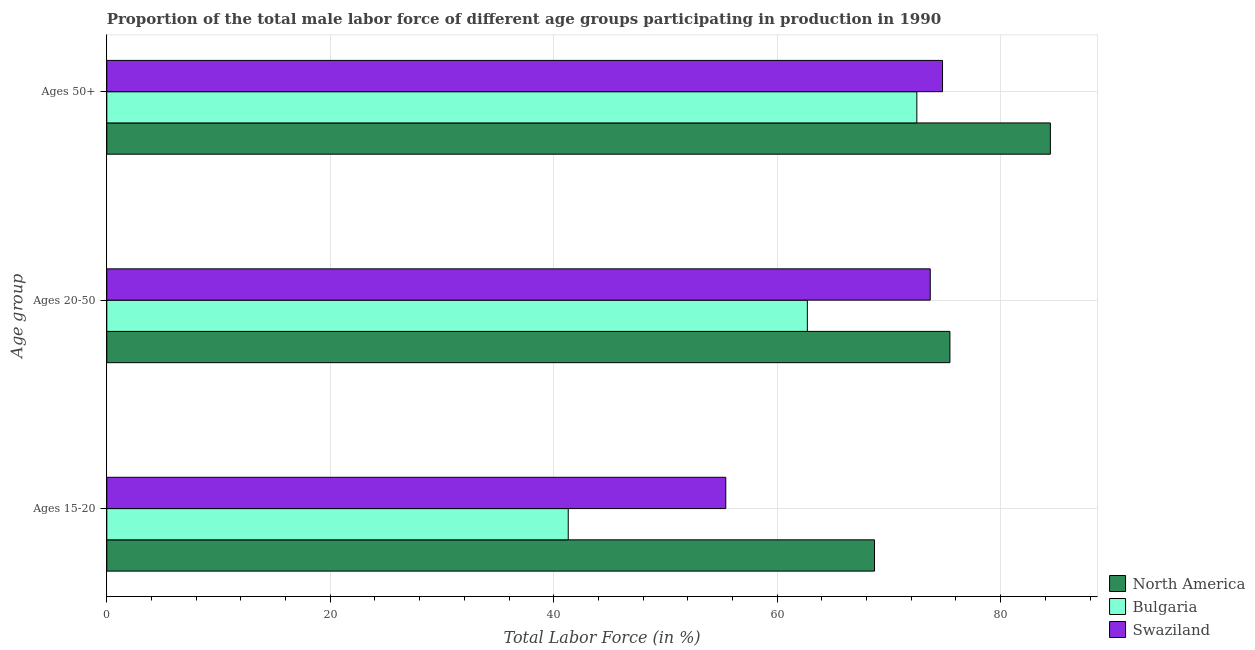Are the number of bars on each tick of the Y-axis equal?
Provide a short and direct response. Yes. What is the label of the 1st group of bars from the top?
Offer a terse response. Ages 50+. What is the percentage of male labor force within the age group 15-20 in Swaziland?
Your answer should be very brief. 55.4. Across all countries, what is the maximum percentage of male labor force within the age group 20-50?
Your answer should be very brief. 75.46. Across all countries, what is the minimum percentage of male labor force within the age group 20-50?
Provide a succinct answer. 62.7. In which country was the percentage of male labor force above age 50 maximum?
Your response must be concise. North America. What is the total percentage of male labor force above age 50 in the graph?
Provide a short and direct response. 231.75. What is the difference between the percentage of male labor force above age 50 in Swaziland and that in Bulgaria?
Provide a succinct answer. 2.3. What is the difference between the percentage of male labor force within the age group 20-50 in North America and the percentage of male labor force above age 50 in Bulgaria?
Give a very brief answer. 2.96. What is the average percentage of male labor force within the age group 20-50 per country?
Ensure brevity in your answer.  70.62. What is the difference between the percentage of male labor force within the age group 15-20 and percentage of male labor force above age 50 in North America?
Keep it short and to the point. -15.74. What is the ratio of the percentage of male labor force above age 50 in North America to that in Bulgaria?
Make the answer very short. 1.16. What is the difference between the highest and the second highest percentage of male labor force above age 50?
Make the answer very short. 9.65. What is the difference between the highest and the lowest percentage of male labor force within the age group 20-50?
Provide a short and direct response. 12.76. In how many countries, is the percentage of male labor force within the age group 15-20 greater than the average percentage of male labor force within the age group 15-20 taken over all countries?
Your answer should be very brief. 2. What does the 3rd bar from the bottom in Ages 50+ represents?
Provide a succinct answer. Swaziland. How many countries are there in the graph?
Keep it short and to the point. 3. Are the values on the major ticks of X-axis written in scientific E-notation?
Make the answer very short. No. Does the graph contain grids?
Ensure brevity in your answer.  Yes. Where does the legend appear in the graph?
Your response must be concise. Bottom right. How many legend labels are there?
Keep it short and to the point. 3. What is the title of the graph?
Your answer should be very brief. Proportion of the total male labor force of different age groups participating in production in 1990. What is the label or title of the X-axis?
Give a very brief answer. Total Labor Force (in %). What is the label or title of the Y-axis?
Keep it short and to the point. Age group. What is the Total Labor Force (in %) of North America in Ages 15-20?
Give a very brief answer. 68.71. What is the Total Labor Force (in %) of Bulgaria in Ages 15-20?
Provide a short and direct response. 41.3. What is the Total Labor Force (in %) of Swaziland in Ages 15-20?
Offer a very short reply. 55.4. What is the Total Labor Force (in %) of North America in Ages 20-50?
Provide a succinct answer. 75.46. What is the Total Labor Force (in %) of Bulgaria in Ages 20-50?
Offer a very short reply. 62.7. What is the Total Labor Force (in %) in Swaziland in Ages 20-50?
Your response must be concise. 73.7. What is the Total Labor Force (in %) in North America in Ages 50+?
Ensure brevity in your answer.  84.45. What is the Total Labor Force (in %) in Bulgaria in Ages 50+?
Your answer should be very brief. 72.5. What is the Total Labor Force (in %) of Swaziland in Ages 50+?
Keep it short and to the point. 74.8. Across all Age group, what is the maximum Total Labor Force (in %) of North America?
Your response must be concise. 84.45. Across all Age group, what is the maximum Total Labor Force (in %) in Bulgaria?
Your response must be concise. 72.5. Across all Age group, what is the maximum Total Labor Force (in %) of Swaziland?
Keep it short and to the point. 74.8. Across all Age group, what is the minimum Total Labor Force (in %) of North America?
Your response must be concise. 68.71. Across all Age group, what is the minimum Total Labor Force (in %) in Bulgaria?
Offer a terse response. 41.3. Across all Age group, what is the minimum Total Labor Force (in %) in Swaziland?
Your answer should be very brief. 55.4. What is the total Total Labor Force (in %) of North America in the graph?
Offer a very short reply. 228.63. What is the total Total Labor Force (in %) of Bulgaria in the graph?
Make the answer very short. 176.5. What is the total Total Labor Force (in %) in Swaziland in the graph?
Give a very brief answer. 203.9. What is the difference between the Total Labor Force (in %) in North America in Ages 15-20 and that in Ages 20-50?
Your response must be concise. -6.75. What is the difference between the Total Labor Force (in %) of Bulgaria in Ages 15-20 and that in Ages 20-50?
Your response must be concise. -21.4. What is the difference between the Total Labor Force (in %) in Swaziland in Ages 15-20 and that in Ages 20-50?
Make the answer very short. -18.3. What is the difference between the Total Labor Force (in %) in North America in Ages 15-20 and that in Ages 50+?
Give a very brief answer. -15.74. What is the difference between the Total Labor Force (in %) in Bulgaria in Ages 15-20 and that in Ages 50+?
Your answer should be compact. -31.2. What is the difference between the Total Labor Force (in %) in Swaziland in Ages 15-20 and that in Ages 50+?
Provide a succinct answer. -19.4. What is the difference between the Total Labor Force (in %) in North America in Ages 20-50 and that in Ages 50+?
Keep it short and to the point. -8.99. What is the difference between the Total Labor Force (in %) of Bulgaria in Ages 20-50 and that in Ages 50+?
Your answer should be compact. -9.8. What is the difference between the Total Labor Force (in %) in Swaziland in Ages 20-50 and that in Ages 50+?
Keep it short and to the point. -1.1. What is the difference between the Total Labor Force (in %) of North America in Ages 15-20 and the Total Labor Force (in %) of Bulgaria in Ages 20-50?
Keep it short and to the point. 6.01. What is the difference between the Total Labor Force (in %) in North America in Ages 15-20 and the Total Labor Force (in %) in Swaziland in Ages 20-50?
Ensure brevity in your answer.  -4.99. What is the difference between the Total Labor Force (in %) of Bulgaria in Ages 15-20 and the Total Labor Force (in %) of Swaziland in Ages 20-50?
Ensure brevity in your answer.  -32.4. What is the difference between the Total Labor Force (in %) of North America in Ages 15-20 and the Total Labor Force (in %) of Bulgaria in Ages 50+?
Give a very brief answer. -3.79. What is the difference between the Total Labor Force (in %) in North America in Ages 15-20 and the Total Labor Force (in %) in Swaziland in Ages 50+?
Keep it short and to the point. -6.09. What is the difference between the Total Labor Force (in %) in Bulgaria in Ages 15-20 and the Total Labor Force (in %) in Swaziland in Ages 50+?
Provide a short and direct response. -33.5. What is the difference between the Total Labor Force (in %) of North America in Ages 20-50 and the Total Labor Force (in %) of Bulgaria in Ages 50+?
Your response must be concise. 2.96. What is the difference between the Total Labor Force (in %) of North America in Ages 20-50 and the Total Labor Force (in %) of Swaziland in Ages 50+?
Offer a terse response. 0.66. What is the average Total Labor Force (in %) in North America per Age group?
Ensure brevity in your answer.  76.21. What is the average Total Labor Force (in %) in Bulgaria per Age group?
Provide a succinct answer. 58.83. What is the average Total Labor Force (in %) in Swaziland per Age group?
Offer a terse response. 67.97. What is the difference between the Total Labor Force (in %) in North America and Total Labor Force (in %) in Bulgaria in Ages 15-20?
Your answer should be compact. 27.41. What is the difference between the Total Labor Force (in %) of North America and Total Labor Force (in %) of Swaziland in Ages 15-20?
Offer a very short reply. 13.31. What is the difference between the Total Labor Force (in %) of Bulgaria and Total Labor Force (in %) of Swaziland in Ages 15-20?
Provide a succinct answer. -14.1. What is the difference between the Total Labor Force (in %) in North America and Total Labor Force (in %) in Bulgaria in Ages 20-50?
Your response must be concise. 12.76. What is the difference between the Total Labor Force (in %) of North America and Total Labor Force (in %) of Swaziland in Ages 20-50?
Your answer should be compact. 1.76. What is the difference between the Total Labor Force (in %) in Bulgaria and Total Labor Force (in %) in Swaziland in Ages 20-50?
Give a very brief answer. -11. What is the difference between the Total Labor Force (in %) in North America and Total Labor Force (in %) in Bulgaria in Ages 50+?
Offer a terse response. 11.95. What is the difference between the Total Labor Force (in %) of North America and Total Labor Force (in %) of Swaziland in Ages 50+?
Provide a succinct answer. 9.65. What is the difference between the Total Labor Force (in %) of Bulgaria and Total Labor Force (in %) of Swaziland in Ages 50+?
Your response must be concise. -2.3. What is the ratio of the Total Labor Force (in %) of North America in Ages 15-20 to that in Ages 20-50?
Provide a succinct answer. 0.91. What is the ratio of the Total Labor Force (in %) of Bulgaria in Ages 15-20 to that in Ages 20-50?
Offer a very short reply. 0.66. What is the ratio of the Total Labor Force (in %) in Swaziland in Ages 15-20 to that in Ages 20-50?
Offer a terse response. 0.75. What is the ratio of the Total Labor Force (in %) of North America in Ages 15-20 to that in Ages 50+?
Your response must be concise. 0.81. What is the ratio of the Total Labor Force (in %) of Bulgaria in Ages 15-20 to that in Ages 50+?
Keep it short and to the point. 0.57. What is the ratio of the Total Labor Force (in %) in Swaziland in Ages 15-20 to that in Ages 50+?
Your answer should be very brief. 0.74. What is the ratio of the Total Labor Force (in %) in North America in Ages 20-50 to that in Ages 50+?
Keep it short and to the point. 0.89. What is the ratio of the Total Labor Force (in %) in Bulgaria in Ages 20-50 to that in Ages 50+?
Your answer should be very brief. 0.86. What is the difference between the highest and the second highest Total Labor Force (in %) of North America?
Keep it short and to the point. 8.99. What is the difference between the highest and the second highest Total Labor Force (in %) of Bulgaria?
Make the answer very short. 9.8. What is the difference between the highest and the second highest Total Labor Force (in %) of Swaziland?
Make the answer very short. 1.1. What is the difference between the highest and the lowest Total Labor Force (in %) in North America?
Provide a short and direct response. 15.74. What is the difference between the highest and the lowest Total Labor Force (in %) of Bulgaria?
Ensure brevity in your answer.  31.2. What is the difference between the highest and the lowest Total Labor Force (in %) in Swaziland?
Give a very brief answer. 19.4. 